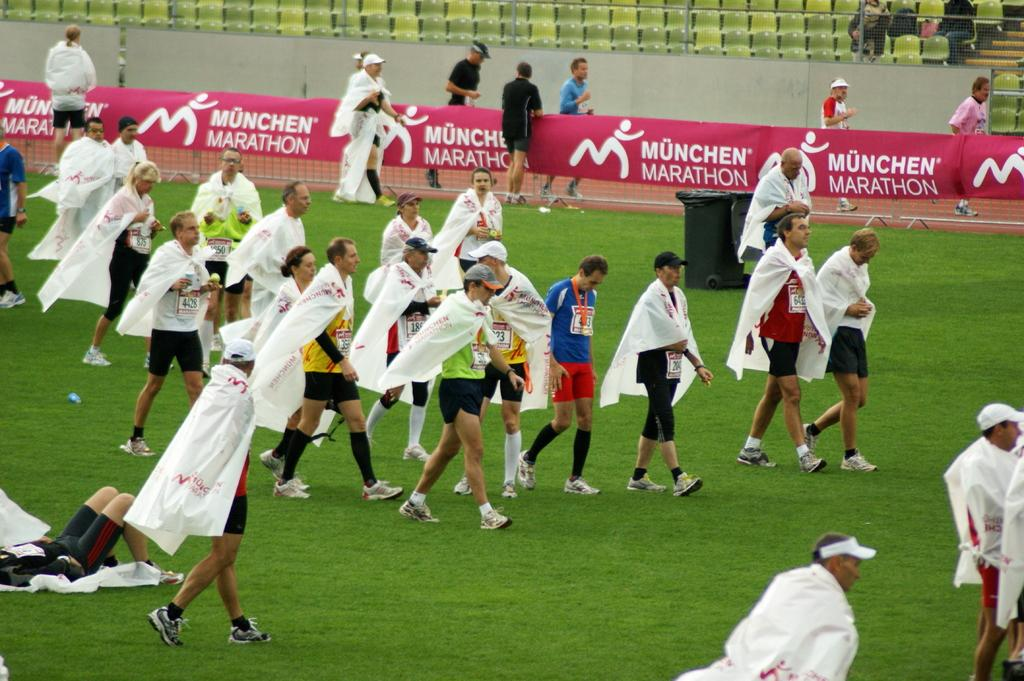<image>
Provide a brief description of the given image. A group of men walking across a field with a banner about a marathon behind him. 